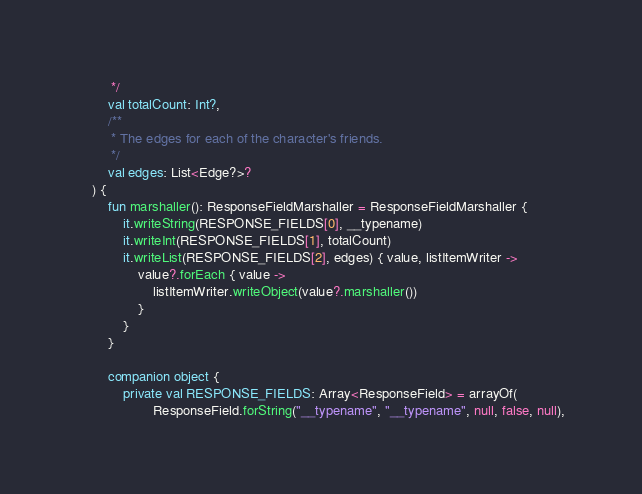<code> <loc_0><loc_0><loc_500><loc_500><_Kotlin_>         */
        val totalCount: Int?,
        /**
         * The edges for each of the character's friends.
         */
        val edges: List<Edge?>?
    ) {
        fun marshaller(): ResponseFieldMarshaller = ResponseFieldMarshaller {
            it.writeString(RESPONSE_FIELDS[0], __typename)
            it.writeInt(RESPONSE_FIELDS[1], totalCount)
            it.writeList(RESPONSE_FIELDS[2], edges) { value, listItemWriter ->
                value?.forEach { value ->
                    listItemWriter.writeObject(value?.marshaller())
                }
            }
        }

        companion object {
            private val RESPONSE_FIELDS: Array<ResponseField> = arrayOf(
                    ResponseField.forString("__typename", "__typename", null, false, null),</code> 